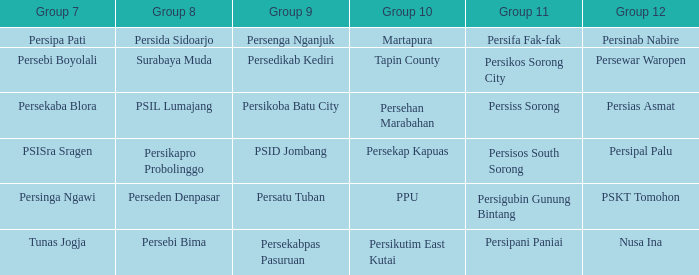Who played in group 11 when Persipal Palu played in group 12? Persisos South Sorong. 